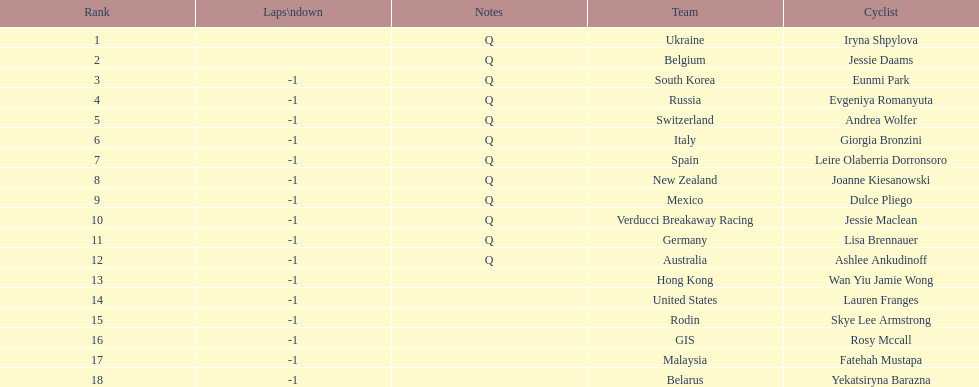How many consecutive notes are there? 12. Can you give me this table as a dict? {'header': ['Rank', 'Laps\\ndown', 'Notes', 'Team', 'Cyclist'], 'rows': [['1', '', 'Q', 'Ukraine', 'Iryna Shpylova'], ['2', '', 'Q', 'Belgium', 'Jessie Daams'], ['3', '-1', 'Q', 'South Korea', 'Eunmi Park'], ['4', '-1', 'Q', 'Russia', 'Evgeniya Romanyuta'], ['5', '-1', 'Q', 'Switzerland', 'Andrea Wolfer'], ['6', '-1', 'Q', 'Italy', 'Giorgia Bronzini'], ['7', '-1', 'Q', 'Spain', 'Leire Olaberria Dorronsoro'], ['8', '-1', 'Q', 'New Zealand', 'Joanne Kiesanowski'], ['9', '-1', 'Q', 'Mexico', 'Dulce Pliego'], ['10', '-1', 'Q', 'Verducci Breakaway Racing', 'Jessie Maclean'], ['11', '-1', 'Q', 'Germany', 'Lisa Brennauer'], ['12', '-1', 'Q', 'Australia', 'Ashlee Ankudinoff'], ['13', '-1', '', 'Hong Kong', 'Wan Yiu Jamie Wong'], ['14', '-1', '', 'United States', 'Lauren Franges'], ['15', '-1', '', 'Rodin', 'Skye Lee Armstrong'], ['16', '-1', '', 'GIS', 'Rosy Mccall'], ['17', '-1', '', 'Malaysia', 'Fatehah Mustapa'], ['18', '-1', '', 'Belarus', 'Yekatsiryna Barazna']]} 